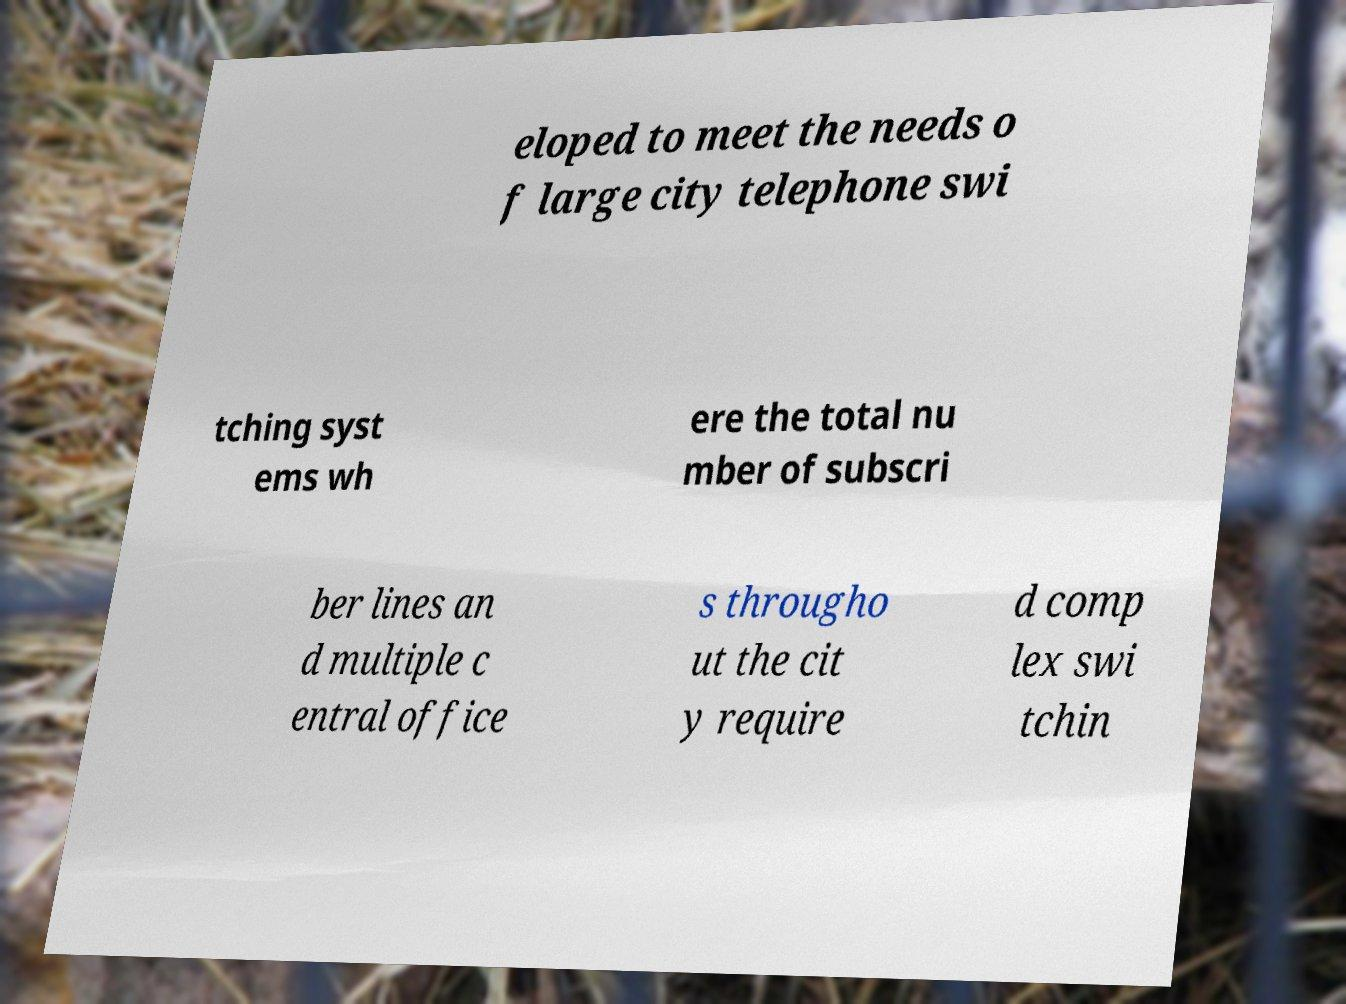Could you assist in decoding the text presented in this image and type it out clearly? eloped to meet the needs o f large city telephone swi tching syst ems wh ere the total nu mber of subscri ber lines an d multiple c entral office s througho ut the cit y require d comp lex swi tchin 